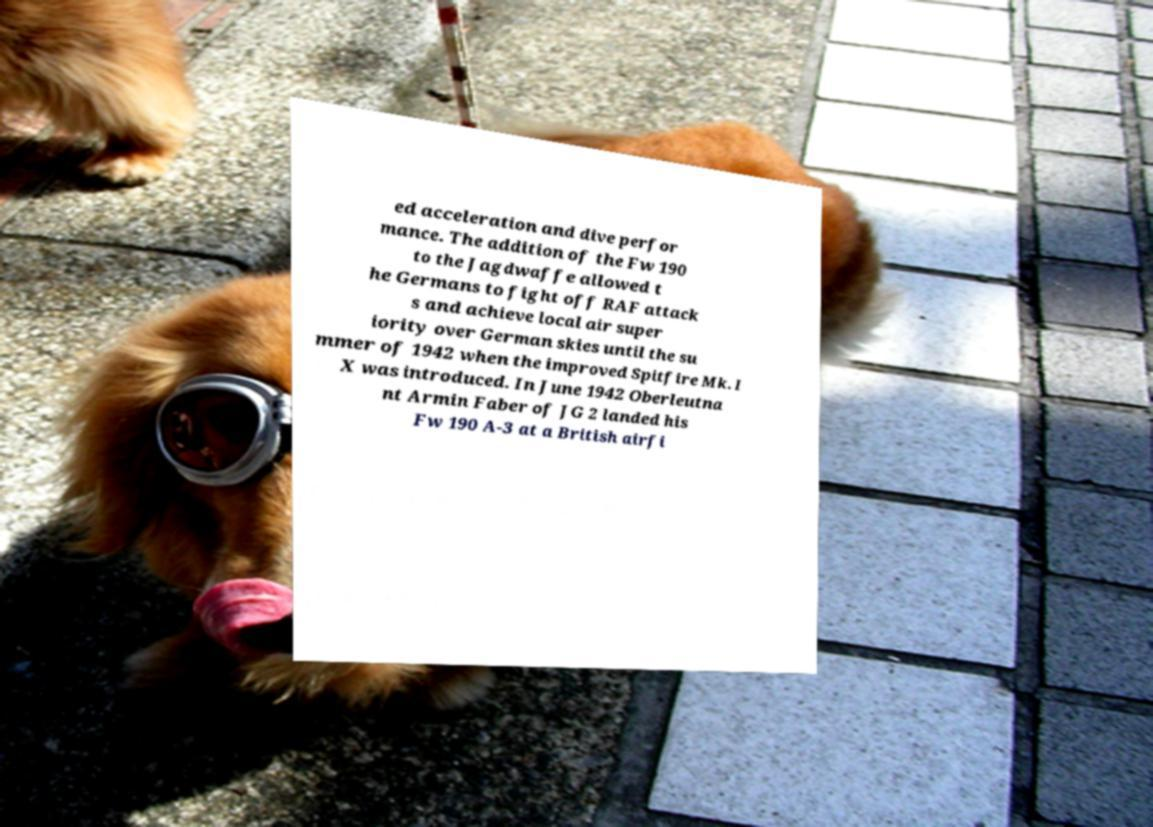Please read and relay the text visible in this image. What does it say? ed acceleration and dive perfor mance. The addition of the Fw 190 to the Jagdwaffe allowed t he Germans to fight off RAF attack s and achieve local air super iority over German skies until the su mmer of 1942 when the improved Spitfire Mk. I X was introduced. In June 1942 Oberleutna nt Armin Faber of JG 2 landed his Fw 190 A-3 at a British airfi 